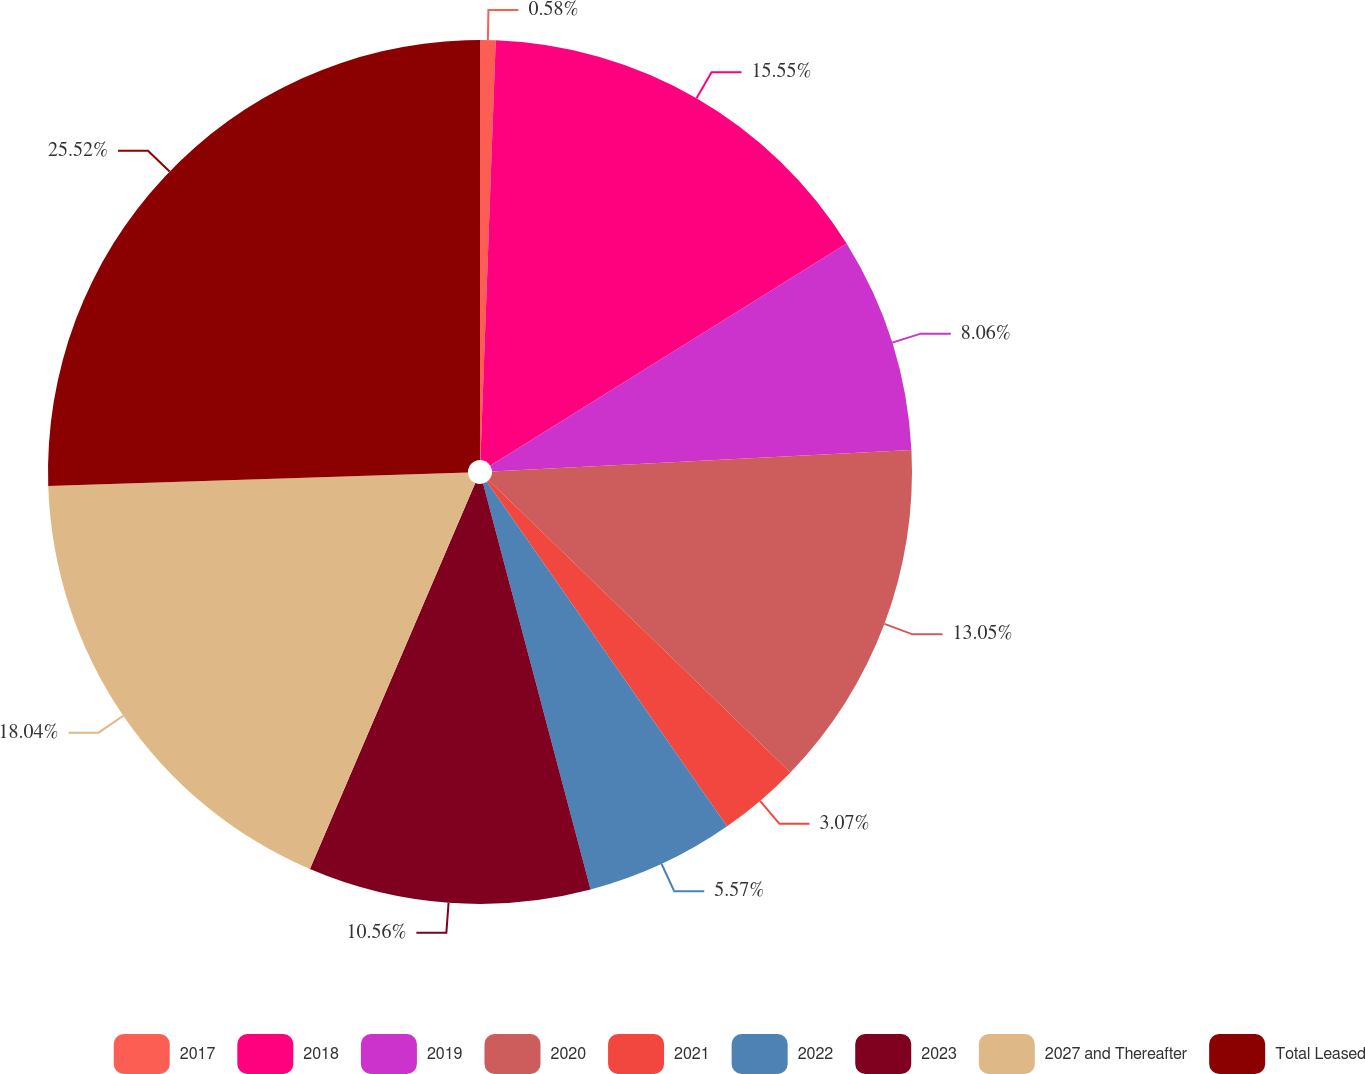Convert chart. <chart><loc_0><loc_0><loc_500><loc_500><pie_chart><fcel>2017<fcel>2018<fcel>2019<fcel>2020<fcel>2021<fcel>2022<fcel>2023<fcel>2027 and Thereafter<fcel>Total Leased<nl><fcel>0.58%<fcel>15.55%<fcel>8.06%<fcel>13.05%<fcel>3.07%<fcel>5.57%<fcel>10.56%<fcel>18.04%<fcel>25.52%<nl></chart> 